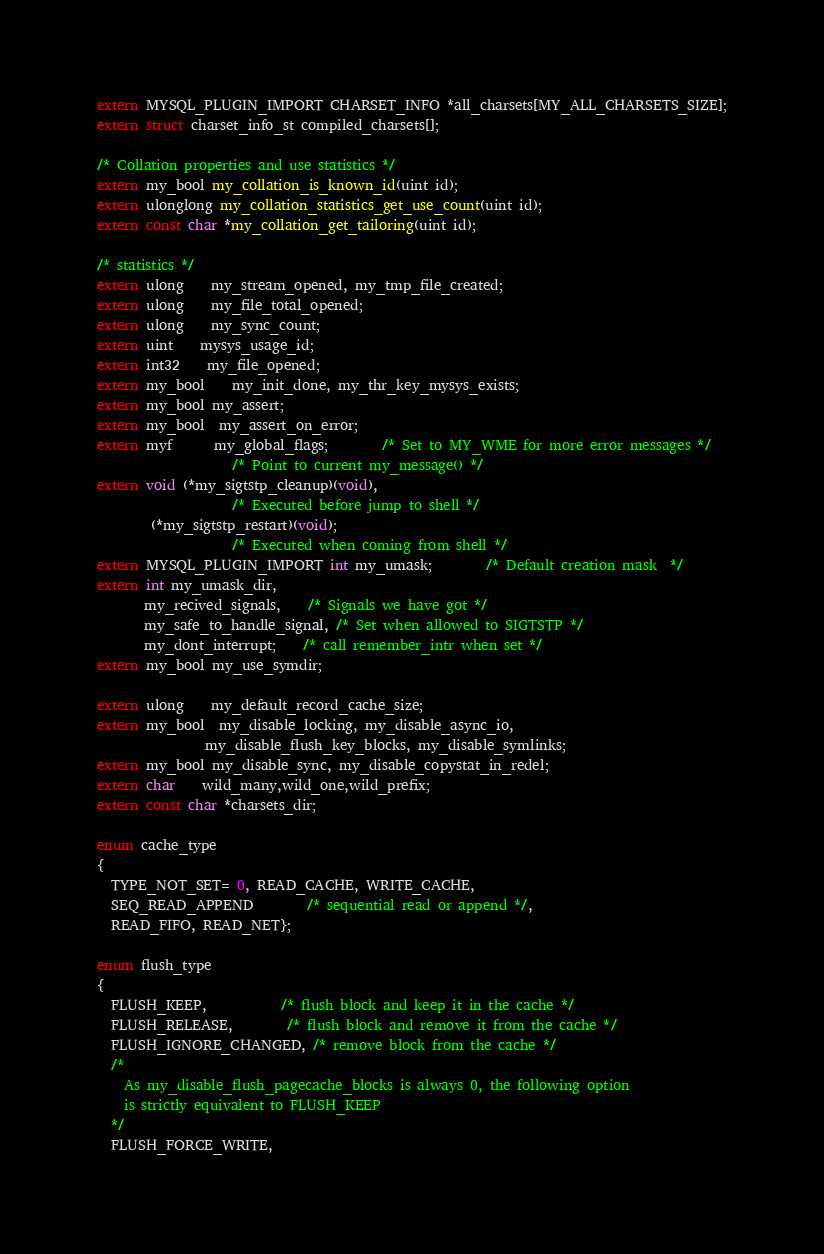Convert code to text. <code><loc_0><loc_0><loc_500><loc_500><_C_>extern MYSQL_PLUGIN_IMPORT CHARSET_INFO *all_charsets[MY_ALL_CHARSETS_SIZE];
extern struct charset_info_st compiled_charsets[];

/* Collation properties and use statistics */
extern my_bool my_collation_is_known_id(uint id);
extern ulonglong my_collation_statistics_get_use_count(uint id);
extern const char *my_collation_get_tailoring(uint id);

/* statistics */
extern ulong    my_stream_opened, my_tmp_file_created;
extern ulong    my_file_total_opened;
extern ulong    my_sync_count;
extern uint	mysys_usage_id;
extern int32    my_file_opened;
extern my_bool	my_init_done, my_thr_key_mysys_exists;
extern my_bool my_assert;
extern my_bool  my_assert_on_error;
extern myf      my_global_flags;        /* Set to MY_WME for more error messages */
					/* Point to current my_message() */
extern void (*my_sigtstp_cleanup)(void),
					/* Executed before jump to shell */
	    (*my_sigtstp_restart)(void);
					/* Executed when coming from shell */
extern MYSQL_PLUGIN_IMPORT int my_umask;		/* Default creation mask  */
extern int my_umask_dir,
	   my_recived_signals,	/* Signals we have got */
	   my_safe_to_handle_signal, /* Set when allowed to SIGTSTP */
	   my_dont_interrupt;	/* call remember_intr when set */
extern my_bool my_use_symdir;

extern ulong	my_default_record_cache_size;
extern my_bool  my_disable_locking, my_disable_async_io,
                my_disable_flush_key_blocks, my_disable_symlinks;
extern my_bool my_disable_sync, my_disable_copystat_in_redel;
extern char	wild_many,wild_one,wild_prefix;
extern const char *charsets_dir;

enum cache_type
{
  TYPE_NOT_SET= 0, READ_CACHE, WRITE_CACHE,
  SEQ_READ_APPEND		/* sequential read or append */,
  READ_FIFO, READ_NET};

enum flush_type
{
  FLUSH_KEEP,           /* flush block and keep it in the cache */
  FLUSH_RELEASE,        /* flush block and remove it from the cache */
  FLUSH_IGNORE_CHANGED, /* remove block from the cache */
  /*
    As my_disable_flush_pagecache_blocks is always 0, the following option
    is strictly equivalent to FLUSH_KEEP
  */
  FLUSH_FORCE_WRITE,</code> 